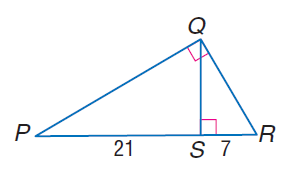Question: Find the measure of the altitude drawn to the hypotenuse.
Choices:
A. \sqrt { 3 }
B. \sqrt { 7 }
C. \sqrt { 21 }
D. \sqrt { 147 }
Answer with the letter. Answer: D 